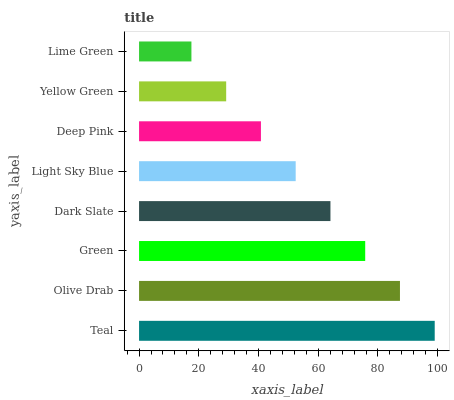Is Lime Green the minimum?
Answer yes or no. Yes. Is Teal the maximum?
Answer yes or no. Yes. Is Olive Drab the minimum?
Answer yes or no. No. Is Olive Drab the maximum?
Answer yes or no. No. Is Teal greater than Olive Drab?
Answer yes or no. Yes. Is Olive Drab less than Teal?
Answer yes or no. Yes. Is Olive Drab greater than Teal?
Answer yes or no. No. Is Teal less than Olive Drab?
Answer yes or no. No. Is Dark Slate the high median?
Answer yes or no. Yes. Is Light Sky Blue the low median?
Answer yes or no. Yes. Is Yellow Green the high median?
Answer yes or no. No. Is Lime Green the low median?
Answer yes or no. No. 